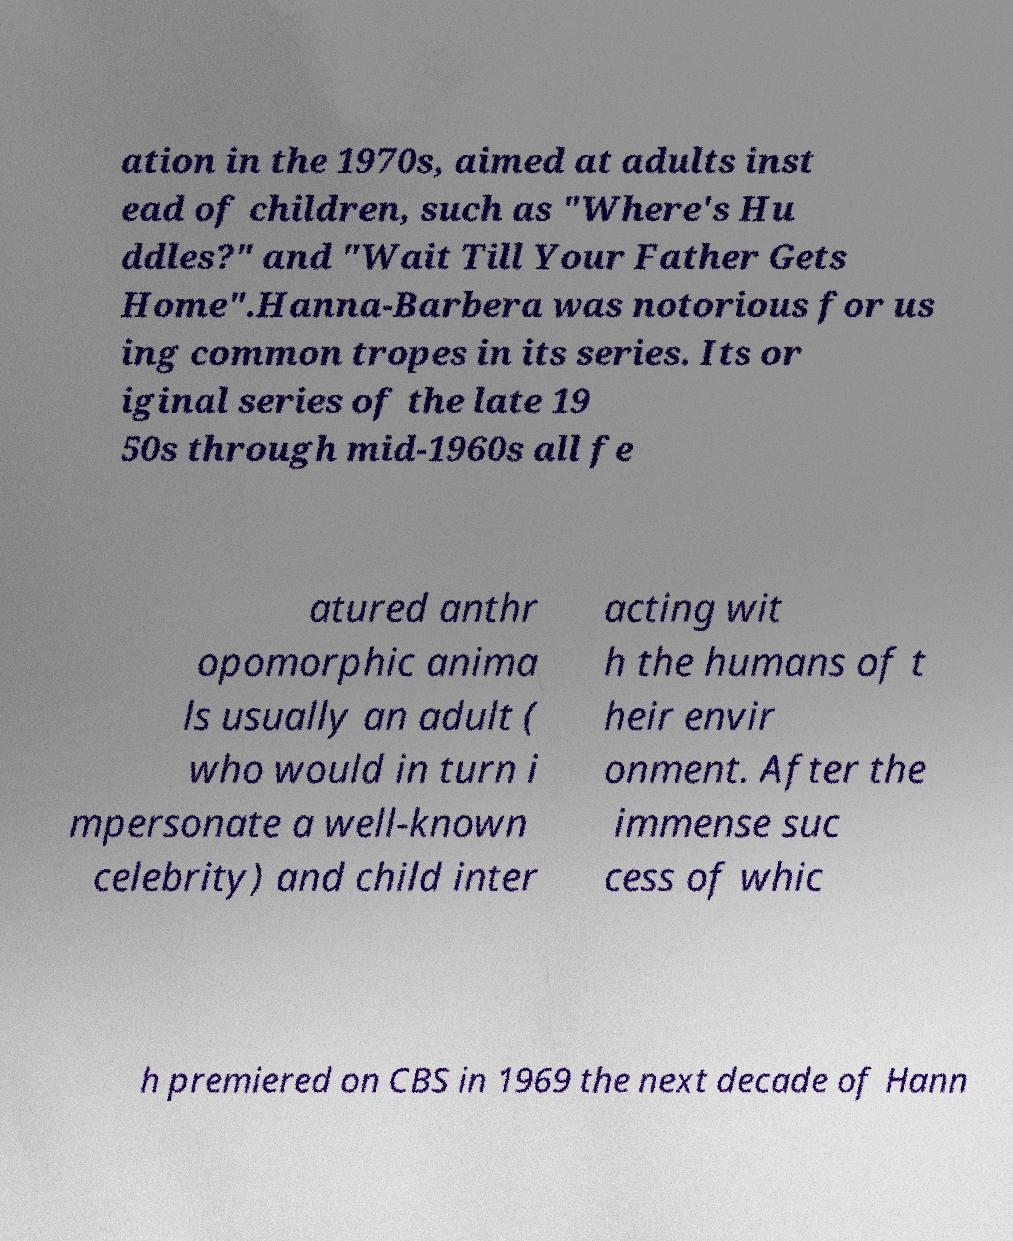Can you read and provide the text displayed in the image?This photo seems to have some interesting text. Can you extract and type it out for me? ation in the 1970s, aimed at adults inst ead of children, such as "Where's Hu ddles?" and "Wait Till Your Father Gets Home".Hanna-Barbera was notorious for us ing common tropes in its series. Its or iginal series of the late 19 50s through mid-1960s all fe atured anthr opomorphic anima ls usually an adult ( who would in turn i mpersonate a well-known celebrity) and child inter acting wit h the humans of t heir envir onment. After the immense suc cess of whic h premiered on CBS in 1969 the next decade of Hann 